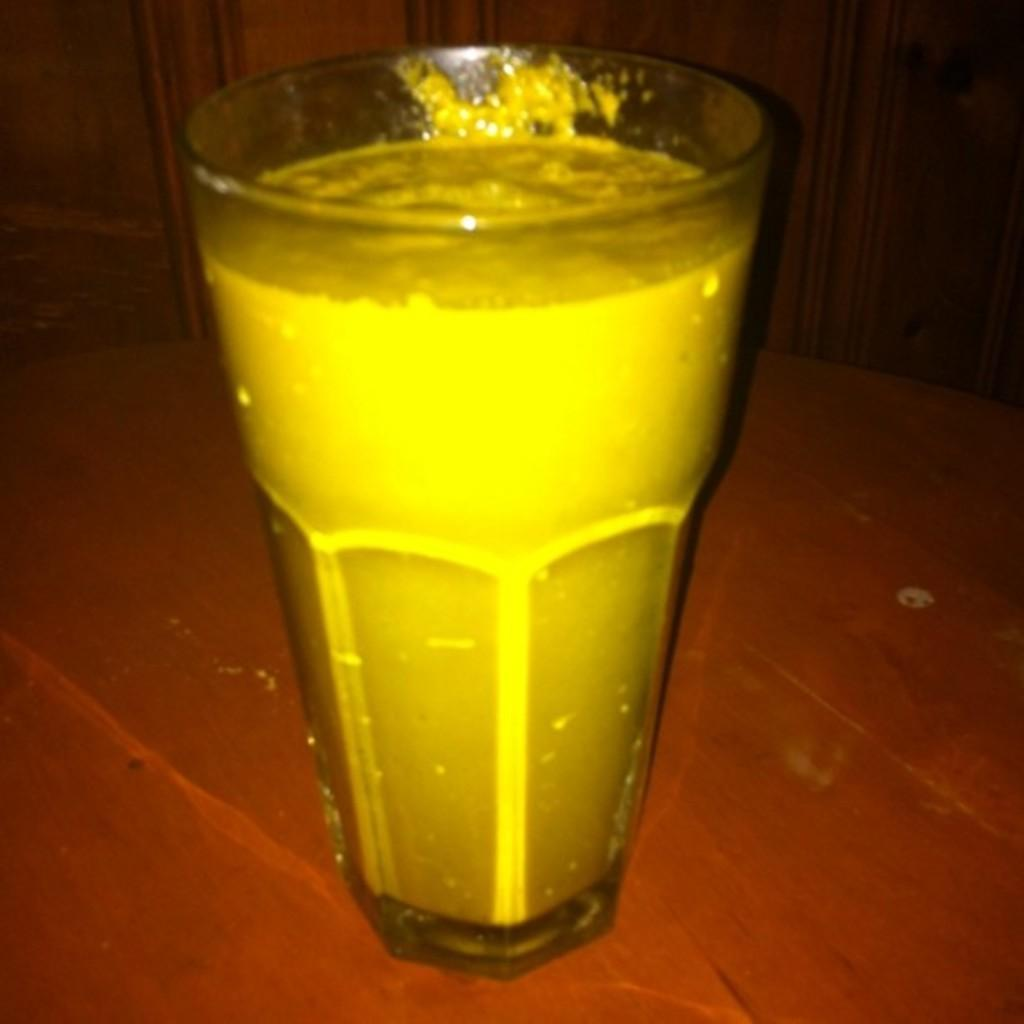What piece of furniture is present in the image? There is a table in the image. What object is placed on the table? There is a glass on the table. How many friends are visible in the image? There are no friends visible in the image, as the facts only mention a table and a glass. 